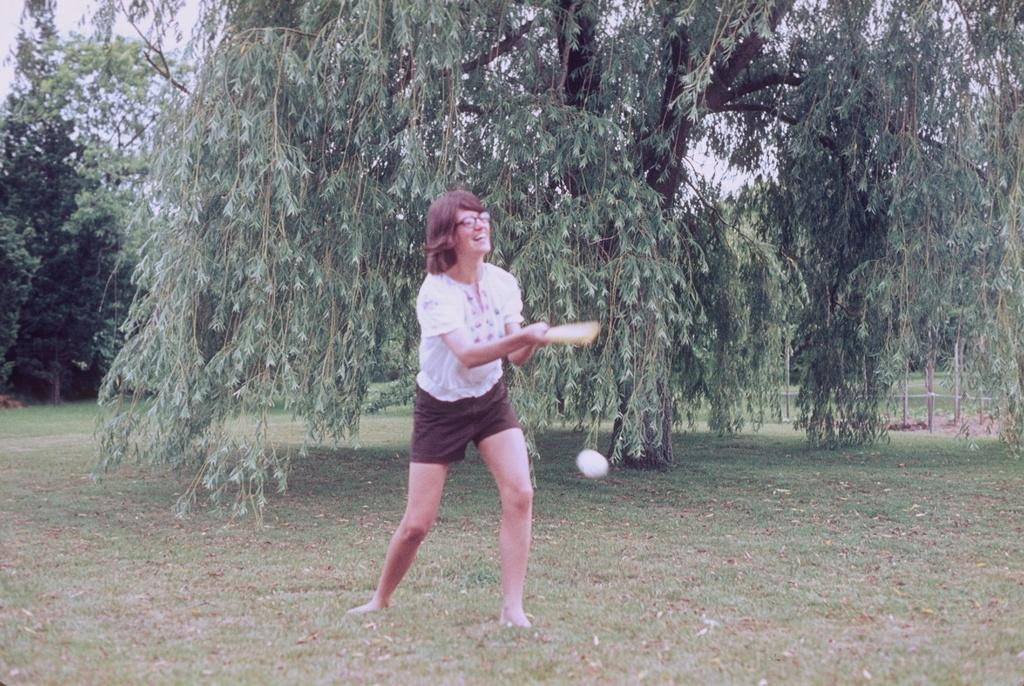Who is present in the image? There is a woman in the image. What is the woman holding in the image? The woman is holding a bat. What is the woman's position in the image? The woman is standing on the ground. What is the woman's facial expression in the image? The woman is smiling. What can be seen at the top of the image? The sky is visible at the top of the image. What type of vegetation is present in the image? There is a tree in the image. What type of nerve can be seen in the image? There is no nerve present in the image. How many bushes are visible in the image? There are no bushes visible in the image; only a tree is present. 